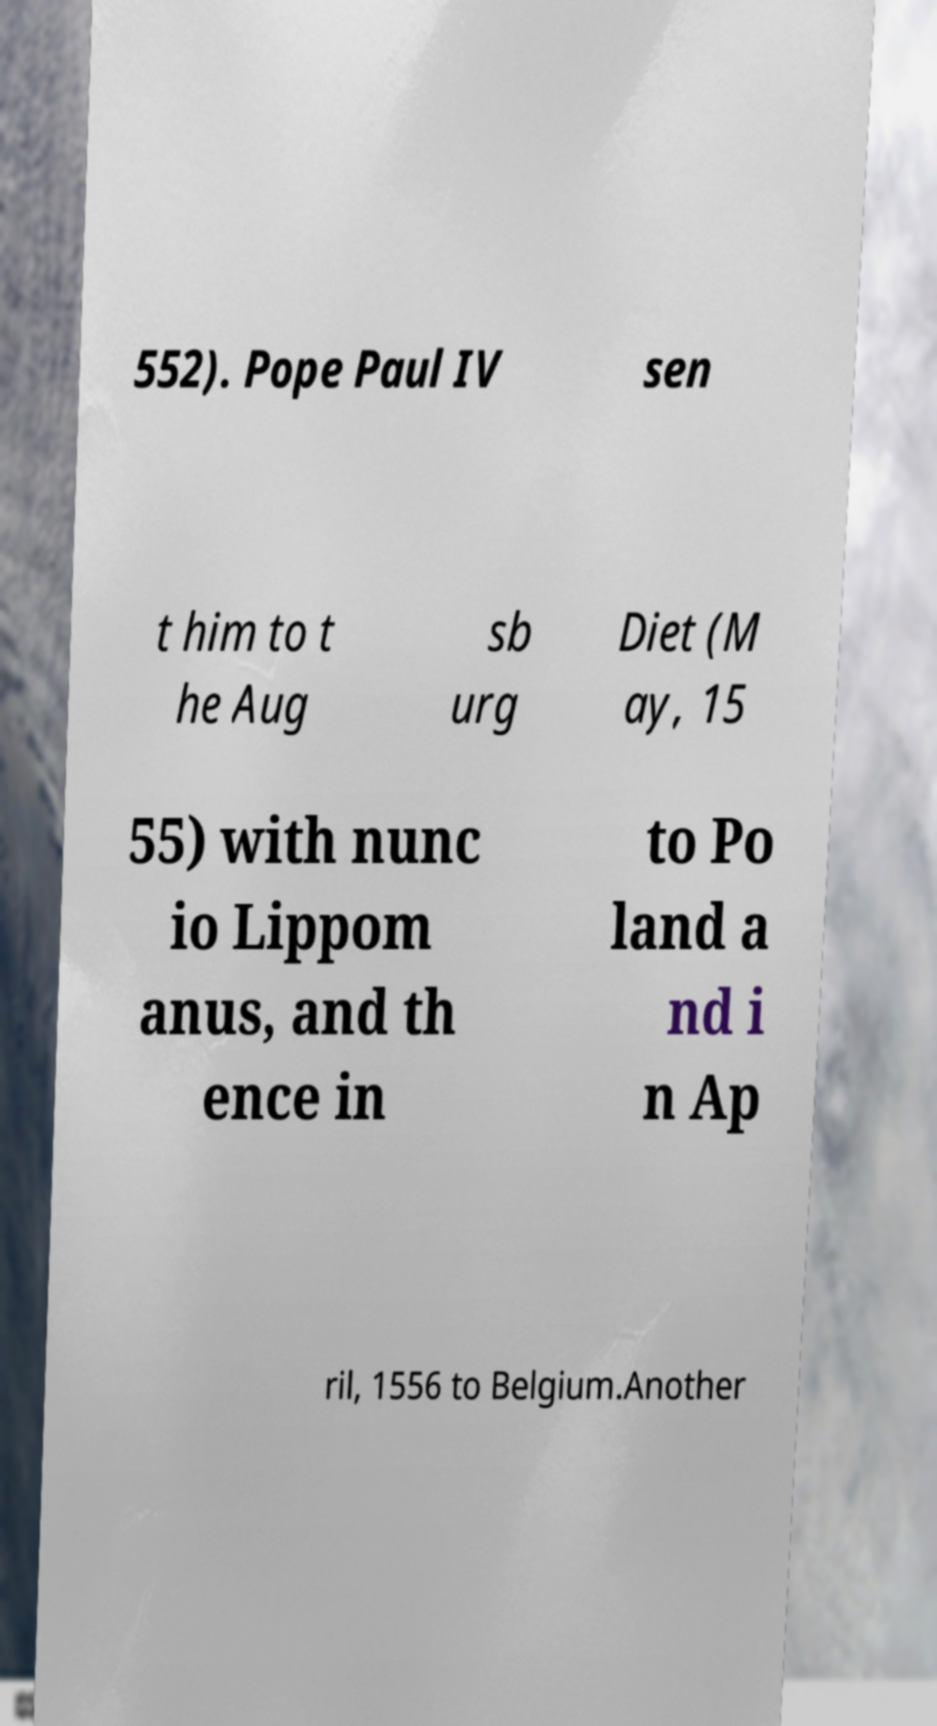Could you extract and type out the text from this image? 552). Pope Paul IV sen t him to t he Aug sb urg Diet (M ay, 15 55) with nunc io Lippom anus, and th ence in to Po land a nd i n Ap ril, 1556 to Belgium.Another 